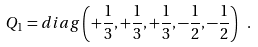<formula> <loc_0><loc_0><loc_500><loc_500>Q _ { 1 } = d i a g \left ( + { \frac { 1 } { 3 } } , + { \frac { 1 } { 3 } } , + { \frac { 1 } { 3 } } , - { \frac { 1 } { 2 } } , - { \frac { 1 } { 2 } } \right ) \ .</formula> 